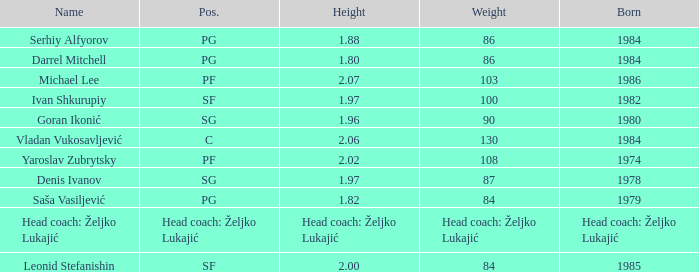Parse the full table. {'header': ['Name', 'Pos.', 'Height', 'Weight', 'Born'], 'rows': [['Serhiy Alfyorov', 'PG', '1.88', '86', '1984'], ['Darrel Mitchell', 'PG', '1.80', '86', '1984'], ['Michael Lee', 'PF', '2.07', '103', '1986'], ['Ivan Shkurupiy', 'SF', '1.97', '100', '1982'], ['Goran Ikonić', 'SG', '1.96', '90', '1980'], ['Vladan Vukosavljević', 'C', '2.06', '130', '1984'], ['Yaroslav Zubrytsky', 'PF', '2.02', '108', '1974'], ['Denis Ivanov', 'SG', '1.97', '87', '1978'], ['Saša Vasiljević', 'PG', '1.82', '84', '1979'], ['Head coach: Željko Lukajić', 'Head coach: Željko Lukajić', 'Head coach: Željko Lukajić', 'Head coach: Željko Lukajić', 'Head coach: Željko Lukajić'], ['Leonid Stefanishin', 'SF', '2.00', '84', '1985']]} What was the weight of Serhiy Alfyorov? 86.0. 